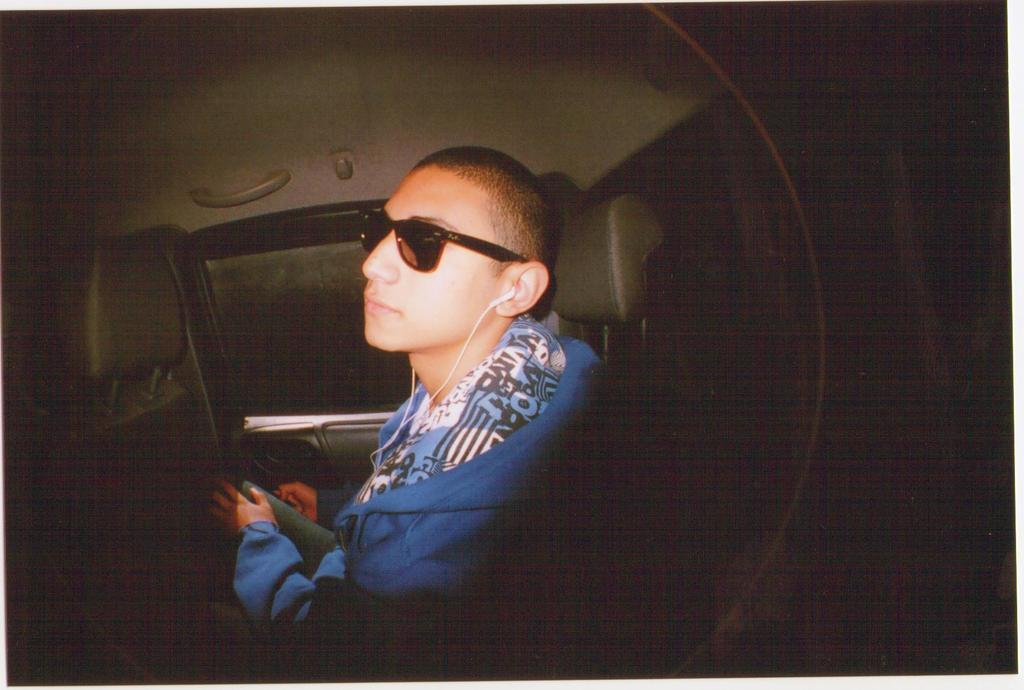What can be seen in the image? There is a person in the image. What is the person wearing? The person is wearing sunglasses and a headset. Where is the person sitting? The person is sitting on a seat of a vehicle. What feature of the vehicle is mentioned? The vehicle has a side window. How would you describe the background of the image? The background of the image is dark in color. How many giants are supporting the vehicle in the image? There are no giants present in the image, and therefore they cannot be supporting the vehicle. What type of blade can be seen in the image? There is no blade present in the image. 